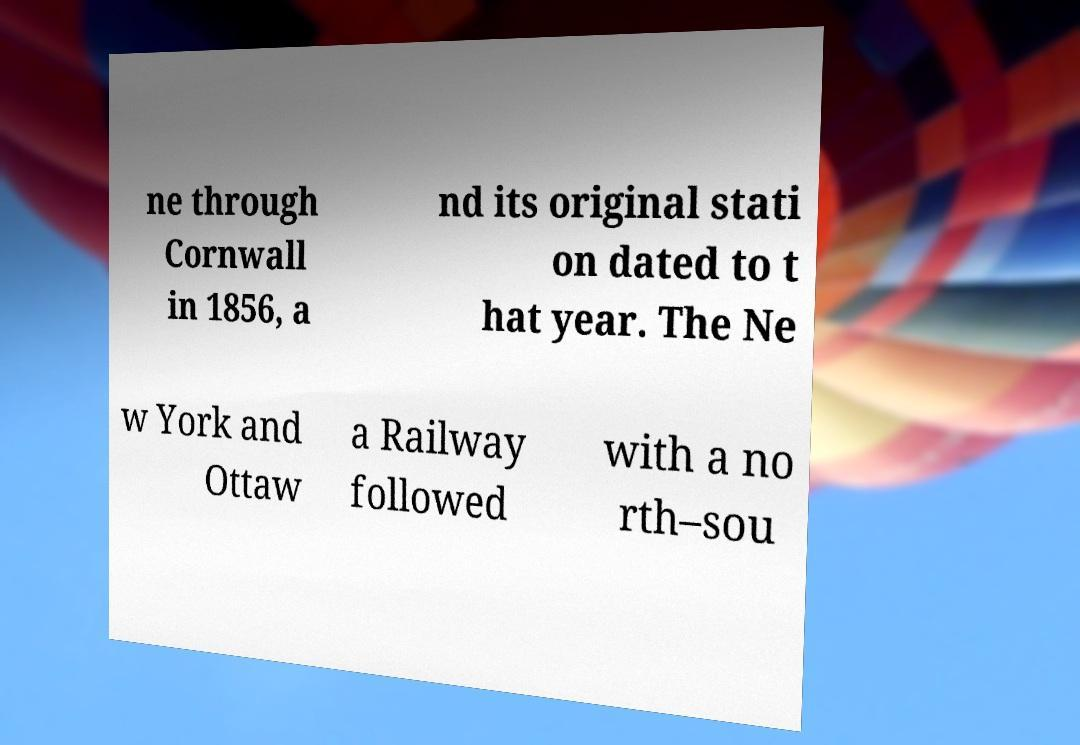Please read and relay the text visible in this image. What does it say? ne through Cornwall in 1856, a nd its original stati on dated to t hat year. The Ne w York and Ottaw a Railway followed with a no rth–sou 